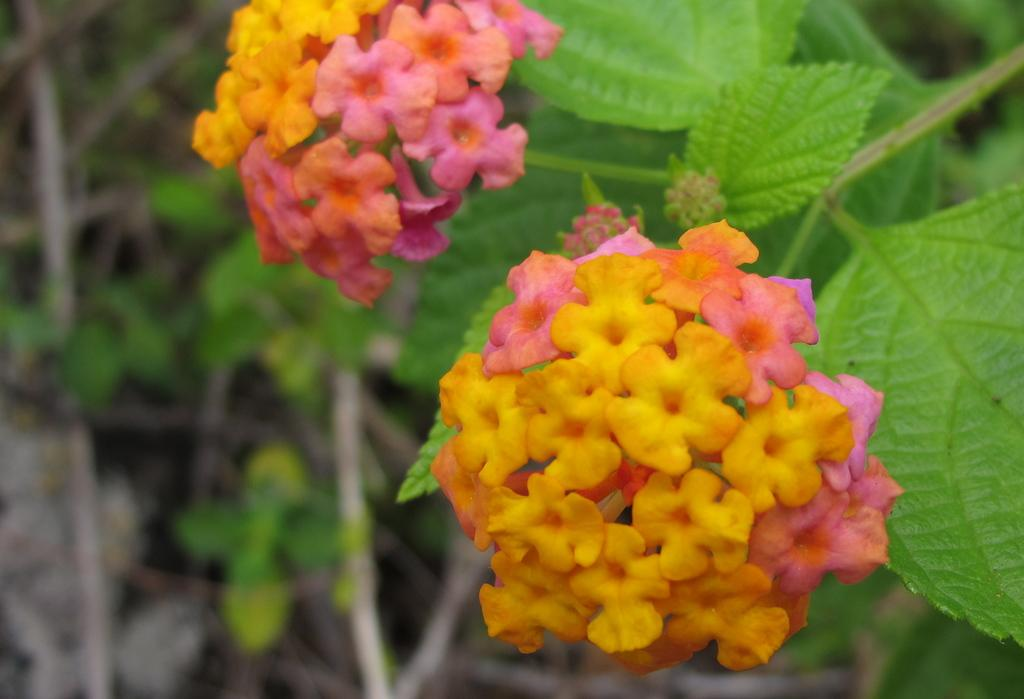What type of plants are featured in the image? There are beautiful colorful flowers in the image. Where are the flowers located? The flowers are on a plant. What can be observed about the background of the flowers? The background of the flowers is blurred. What type of quince is being whipped while reading a book in the image? There is no quince, whip, or book present in the image; it features beautiful colorful flowers on a plant with a blurred background. 